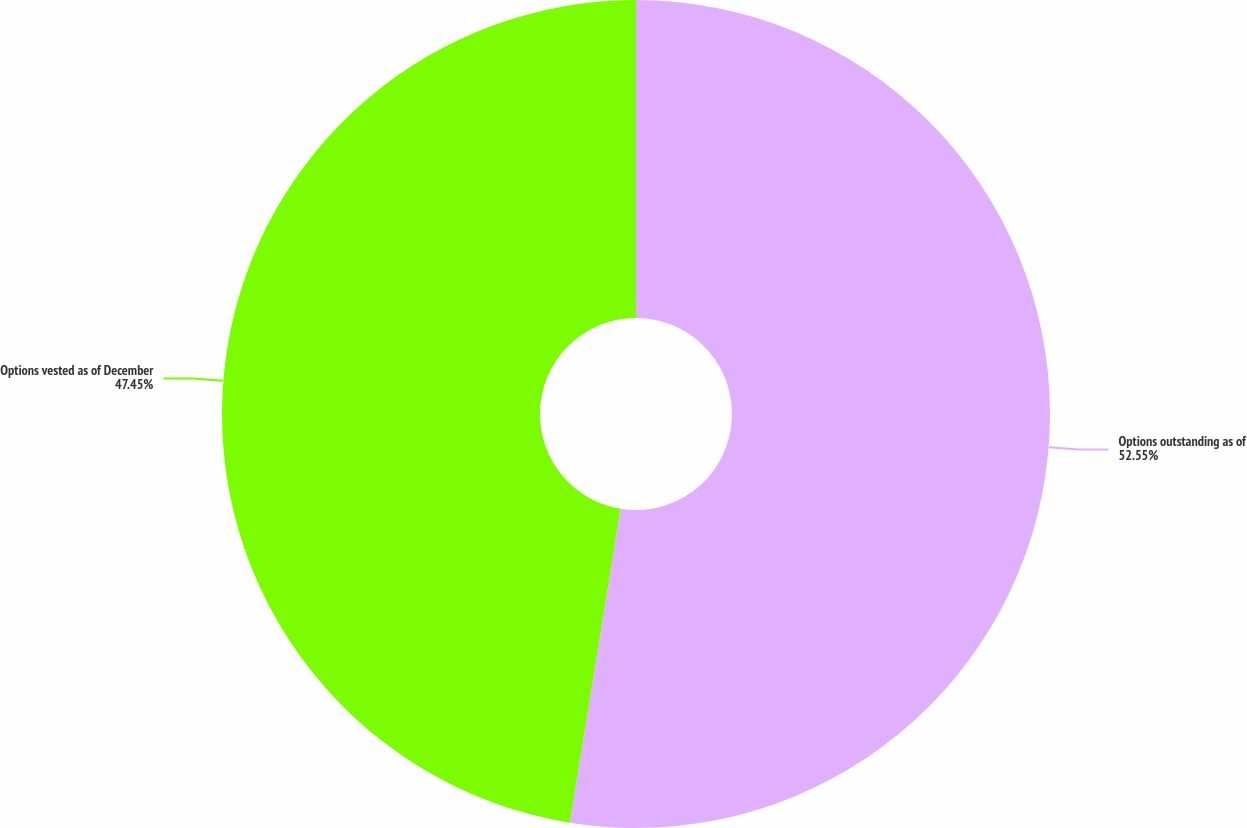Convert chart. <chart><loc_0><loc_0><loc_500><loc_500><pie_chart><fcel>Options outstanding as of<fcel>Options vested as of December<nl><fcel>52.55%<fcel>47.45%<nl></chart> 